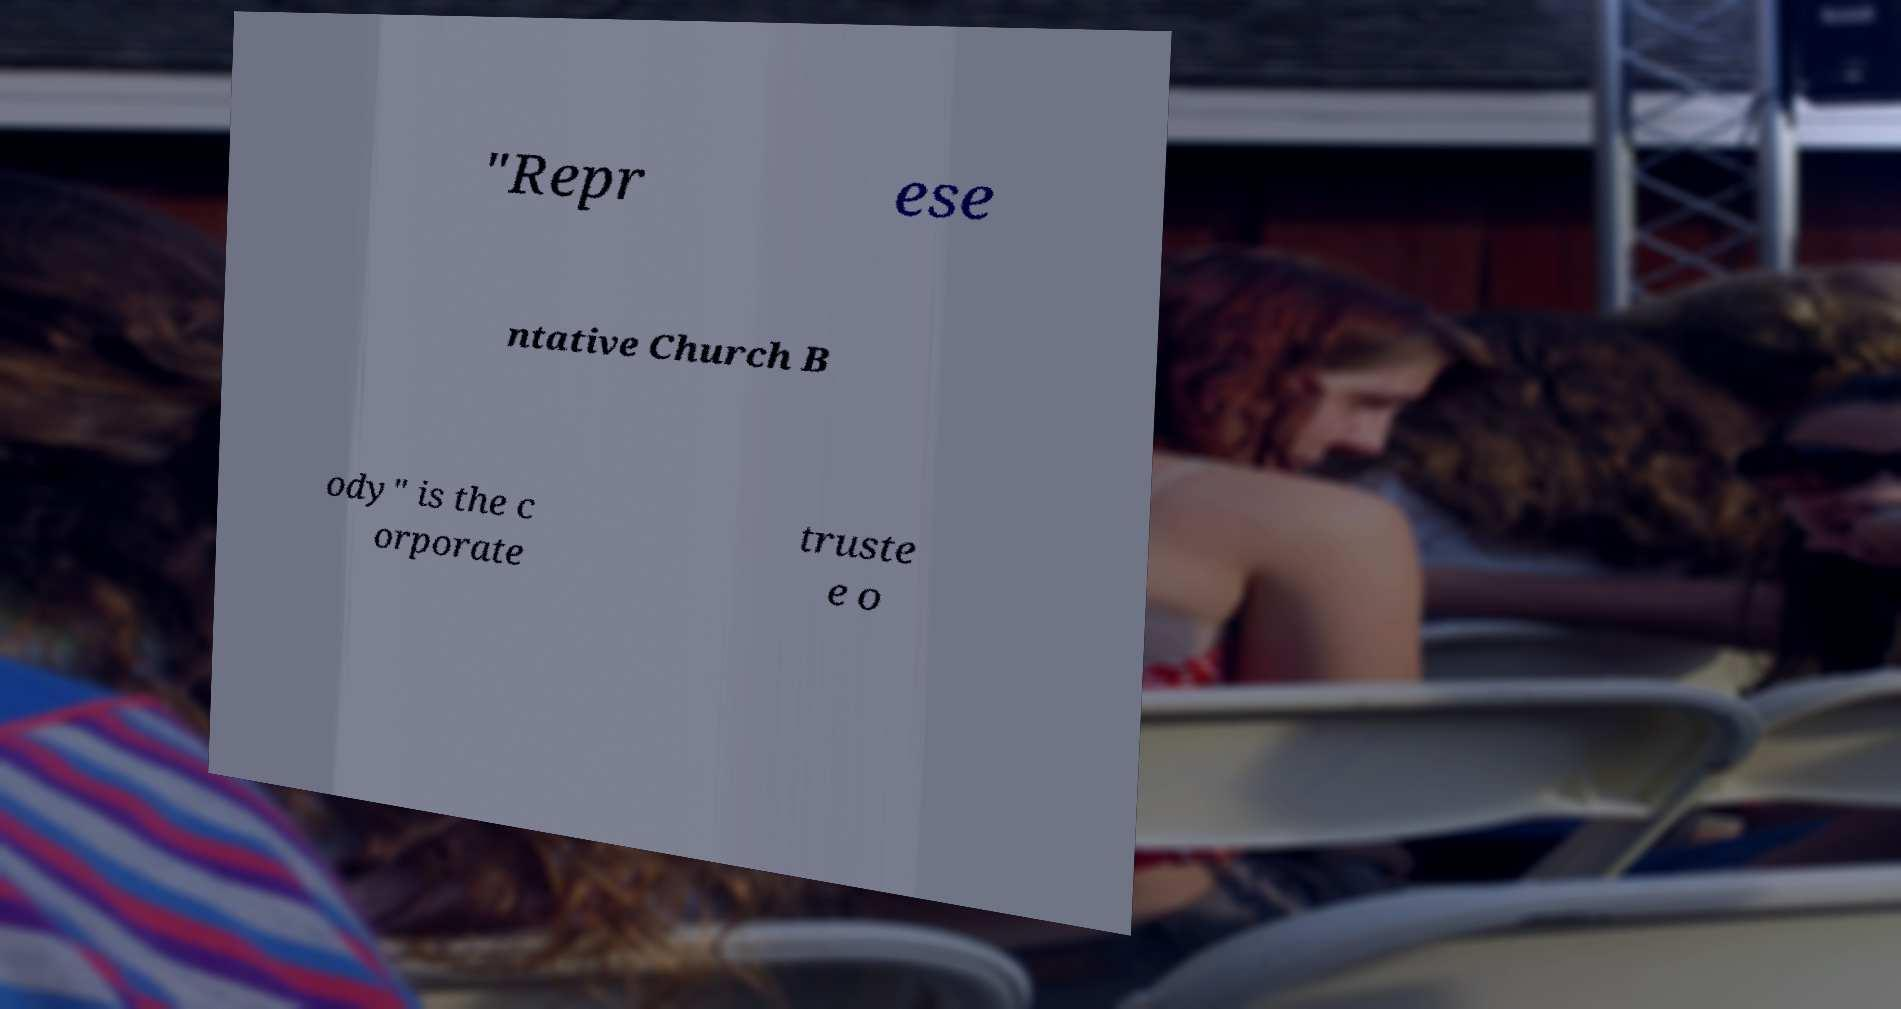Could you assist in decoding the text presented in this image and type it out clearly? "Repr ese ntative Church B ody" is the c orporate truste e o 